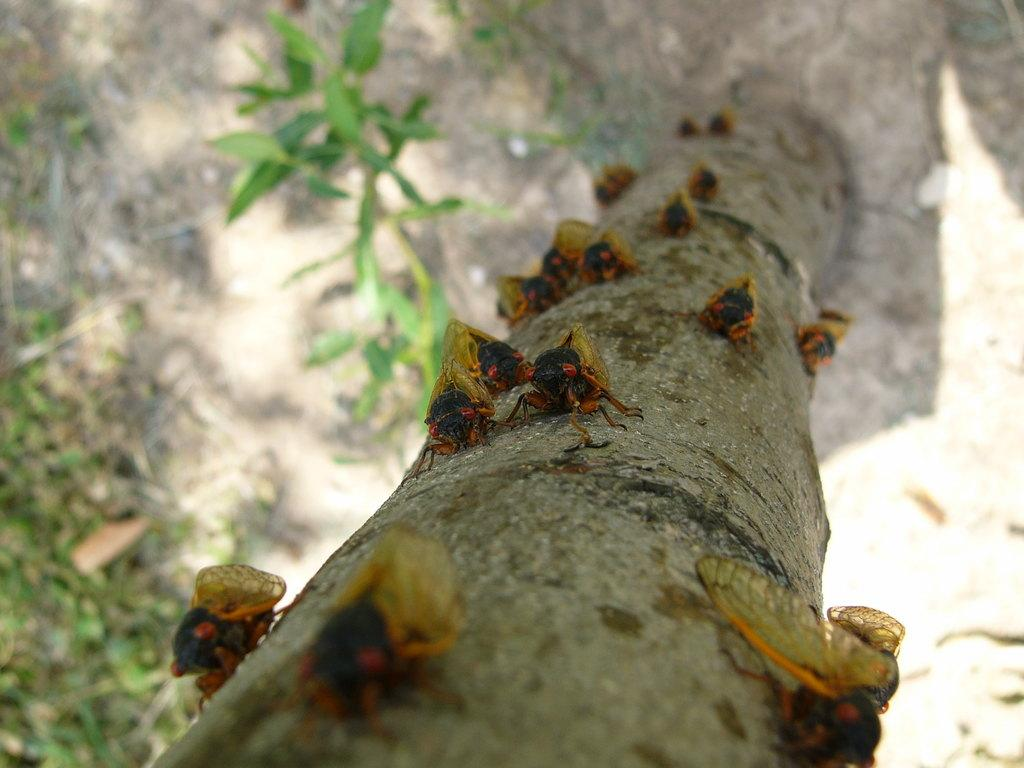What is on the trunk of the tree in the image? There are insects on the trunk of the tree in the image. What colors are the insects? The insects are in red, black, and yellow colors. What can be seen in the background of the image? There is ground and grass visible in the background of the image. How many women are attempting to self-identify in the image? There are no women or self-identification attempts present in the image; it features insects on a tree trunk with a grassy background. 